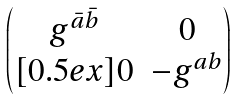<formula> <loc_0><loc_0><loc_500><loc_500>\begin{pmatrix} { g } ^ { \bar { a } \bar { b } } & 0 \\ [ 0 . 5 e x ] 0 & - { g } ^ { a b } \end{pmatrix}</formula> 